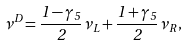Convert formula to latex. <formula><loc_0><loc_0><loc_500><loc_500>\nu ^ { D } = \frac { 1 - \gamma _ { 5 } } { 2 } \nu _ { L } + \frac { 1 + \gamma _ { 5 } } { 2 } \nu _ { R } \, ,</formula> 